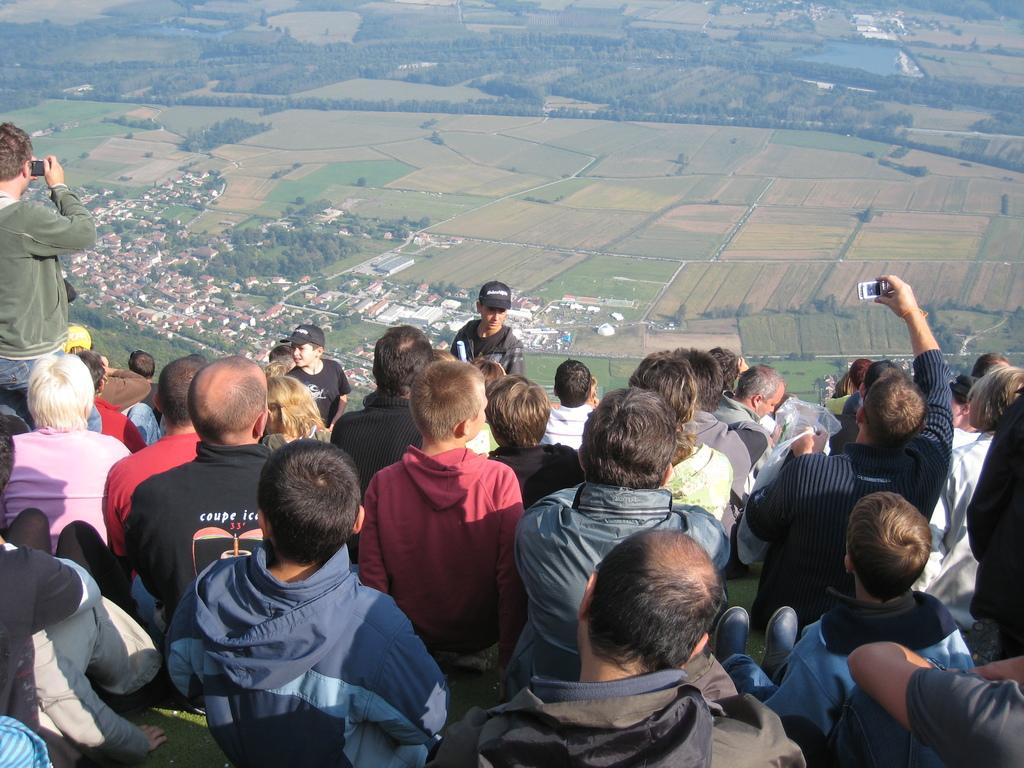What are the majority of people in the image doing? Most of the people in the image are sitting. Are there any other activities being performed by the people in the image? Yes, some people in the image are taking pictures. What type of coal is being used to create the artwork in the image? There is no artwork or coal present in the image; it features people sitting and taking pictures. 